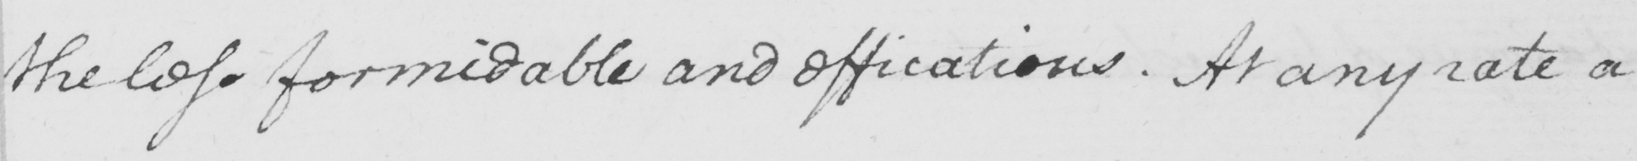What text is written in this handwritten line? the less formidable and efficatious . At any rate a 